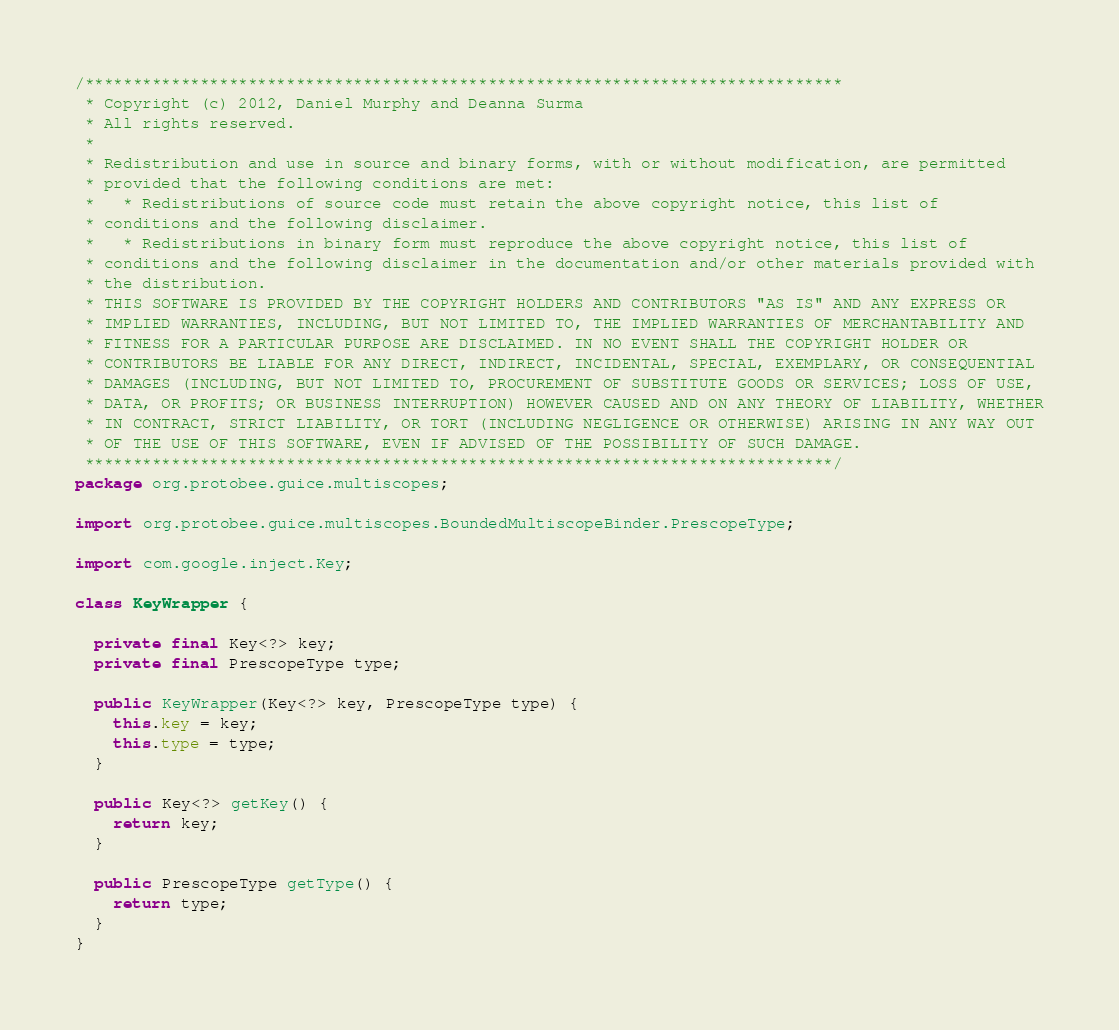Convert code to text. <code><loc_0><loc_0><loc_500><loc_500><_Java_>/*******************************************************************************
 * Copyright (c) 2012, Daniel Murphy and Deanna Surma
 * All rights reserved.
 * 
 * Redistribution and use in source and binary forms, with or without modification, are permitted
 * provided that the following conditions are met:
 *   * Redistributions of source code must retain the above copyright notice, this list of
 * conditions and the following disclaimer.
 *   * Redistributions in binary form must reproduce the above copyright notice, this list of
 * conditions and the following disclaimer in the documentation and/or other materials provided with
 * the distribution.
 * THIS SOFTWARE IS PROVIDED BY THE COPYRIGHT HOLDERS AND CONTRIBUTORS "AS IS" AND ANY EXPRESS OR
 * IMPLIED WARRANTIES, INCLUDING, BUT NOT LIMITED TO, THE IMPLIED WARRANTIES OF MERCHANTABILITY AND
 * FITNESS FOR A PARTICULAR PURPOSE ARE DISCLAIMED. IN NO EVENT SHALL THE COPYRIGHT HOLDER OR
 * CONTRIBUTORS BE LIABLE FOR ANY DIRECT, INDIRECT, INCIDENTAL, SPECIAL, EXEMPLARY, OR CONSEQUENTIAL
 * DAMAGES (INCLUDING, BUT NOT LIMITED TO, PROCUREMENT OF SUBSTITUTE GOODS OR SERVICES; LOSS OF USE,
 * DATA, OR PROFITS; OR BUSINESS INTERRUPTION) HOWEVER CAUSED AND ON ANY THEORY OF LIABILITY, WHETHER
 * IN CONTRACT, STRICT LIABILITY, OR TORT (INCLUDING NEGLIGENCE OR OTHERWISE) ARISING IN ANY WAY OUT
 * OF THE USE OF THIS SOFTWARE, EVEN IF ADVISED OF THE POSSIBILITY OF SUCH DAMAGE.
 ******************************************************************************/
package org.protobee.guice.multiscopes;

import org.protobee.guice.multiscopes.BoundedMultiscopeBinder.PrescopeType;

import com.google.inject.Key;

class KeyWrapper {

  private final Key<?> key;
  private final PrescopeType type;

  public KeyWrapper(Key<?> key, PrescopeType type) {
    this.key = key;
    this.type = type;
  }

  public Key<?> getKey() {
    return key;
  }
  
  public PrescopeType getType() {
    return type;
  }
}
</code> 